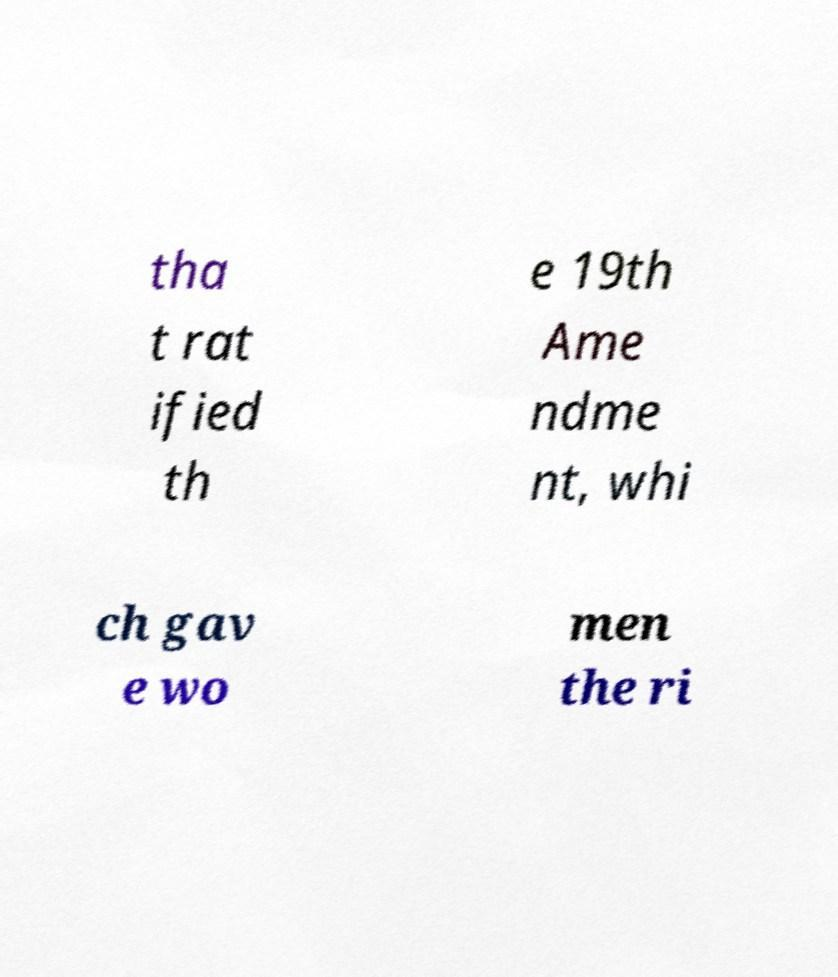Can you accurately transcribe the text from the provided image for me? tha t rat ified th e 19th Ame ndme nt, whi ch gav e wo men the ri 